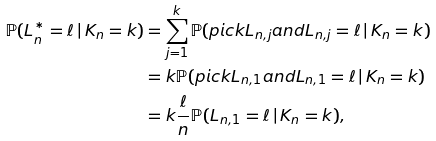<formula> <loc_0><loc_0><loc_500><loc_500>\mathbb { P } ( L _ { n } ^ { * } = \ell \, | \, K _ { n } = k ) & = \sum _ { j = 1 } ^ { k } \mathbb { P } ( p i c k L _ { n , j } a n d L _ { n , j } = \ell \, | \, K _ { n } = k ) \\ & = k \mathbb { P } ( p i c k L _ { n , 1 } a n d L _ { n , 1 } = \ell \, | \, K _ { n } = k ) \\ & = k \frac { \ell } { n } \mathbb { P } ( L _ { n , 1 } = \ell \, | \, K _ { n } = k ) ,</formula> 